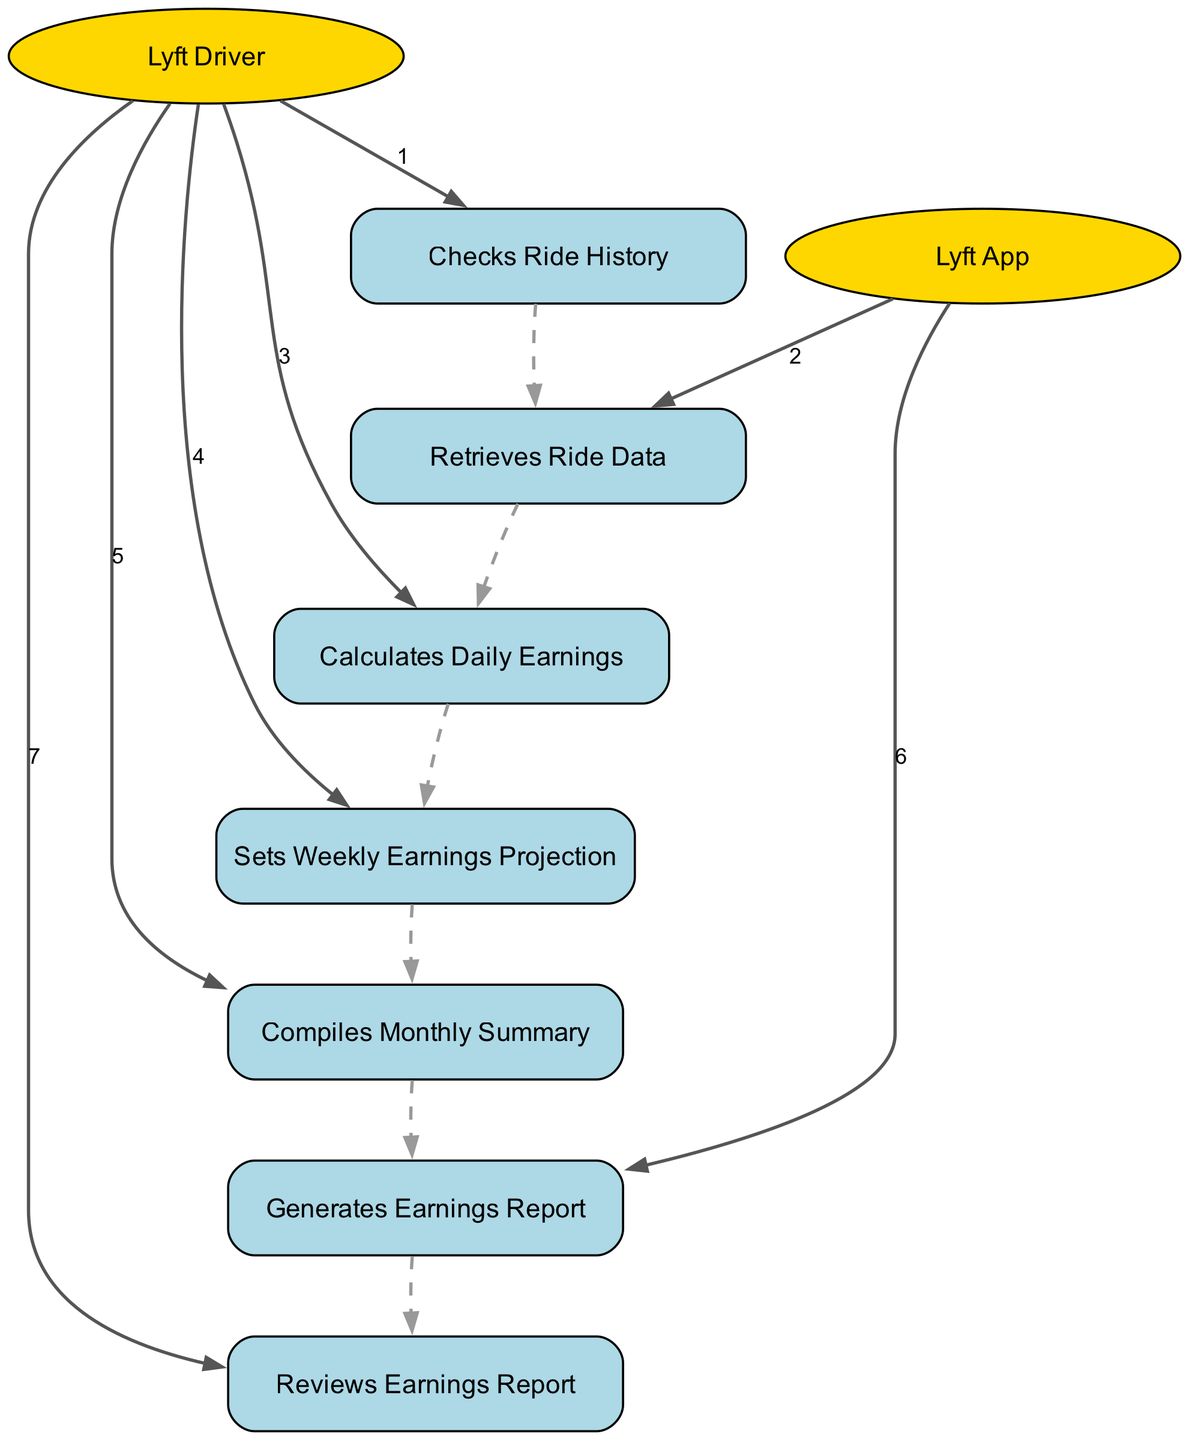What action does the Lyft Driver take first? The sequence diagram begins with the Lyft Driver performing the action of checking their ride history, as indicated by the first action listed in the sequence.
Answer: Checks Ride History How many major actions are shown in the diagram? By counting each unique action taken, we find there are a total of seven distinct actions displayed in the sequence diagram.
Answer: Seven Which actor retrieves the ride data? Analyzing the sequence, it is clear that the Lyft App is responsible for retrieving the ride data after the Lyft Driver checks their ride history.
Answer: Lyft App What does the Lyft Driver do after calculating daily earnings? The sequence shows that subsequent to calculating daily earnings, the Lyft Driver sets a weekly earnings projection as the next logical action in the workflow.
Answer: Sets Weekly Earnings Projection Which action is performed before the Lyft App generates the earnings report? Reviewing the diagram flow, the Lyft Driver compiles the monthly summary prior to the Lyft App generating the earnings report, making this the necessary preceding action.
Answer: Compiles Monthly Summary How does the Lyft Driver use the earnings report? According to the final action in the sequence, the Lyft Driver reviews the earnings report to analyze trends and explore ways to improve their earnings.
Answer: Reviews Earnings Report What is the relationship between the actions of "Calculates Daily Earnings" and "Compiles Monthly Summary"? From the sequence analysis, after the Lyft Driver calculates their daily earnings, they aggregate those daily totals into a monthly summary, showing a direct progression from daily to monthly calculations.
Answer: Daily to Monthly Which actor is involved in generating the earnings report? The Lyft App is the specified actor that performs the action of generating the earnings report for the Lyft Driver to analyze their income.
Answer: Lyft App 